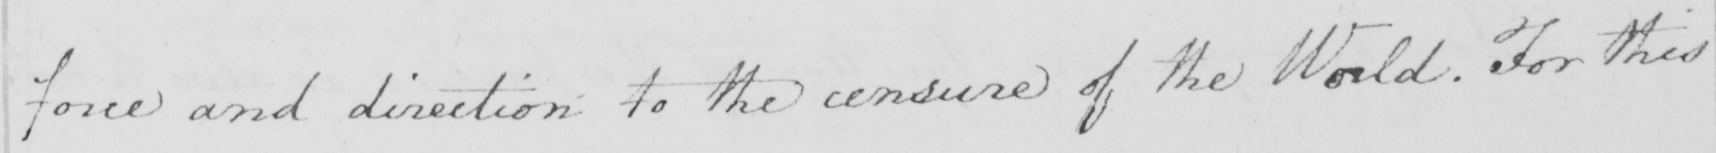Please transcribe the handwritten text in this image. force and direction to the censure of the World . For this 